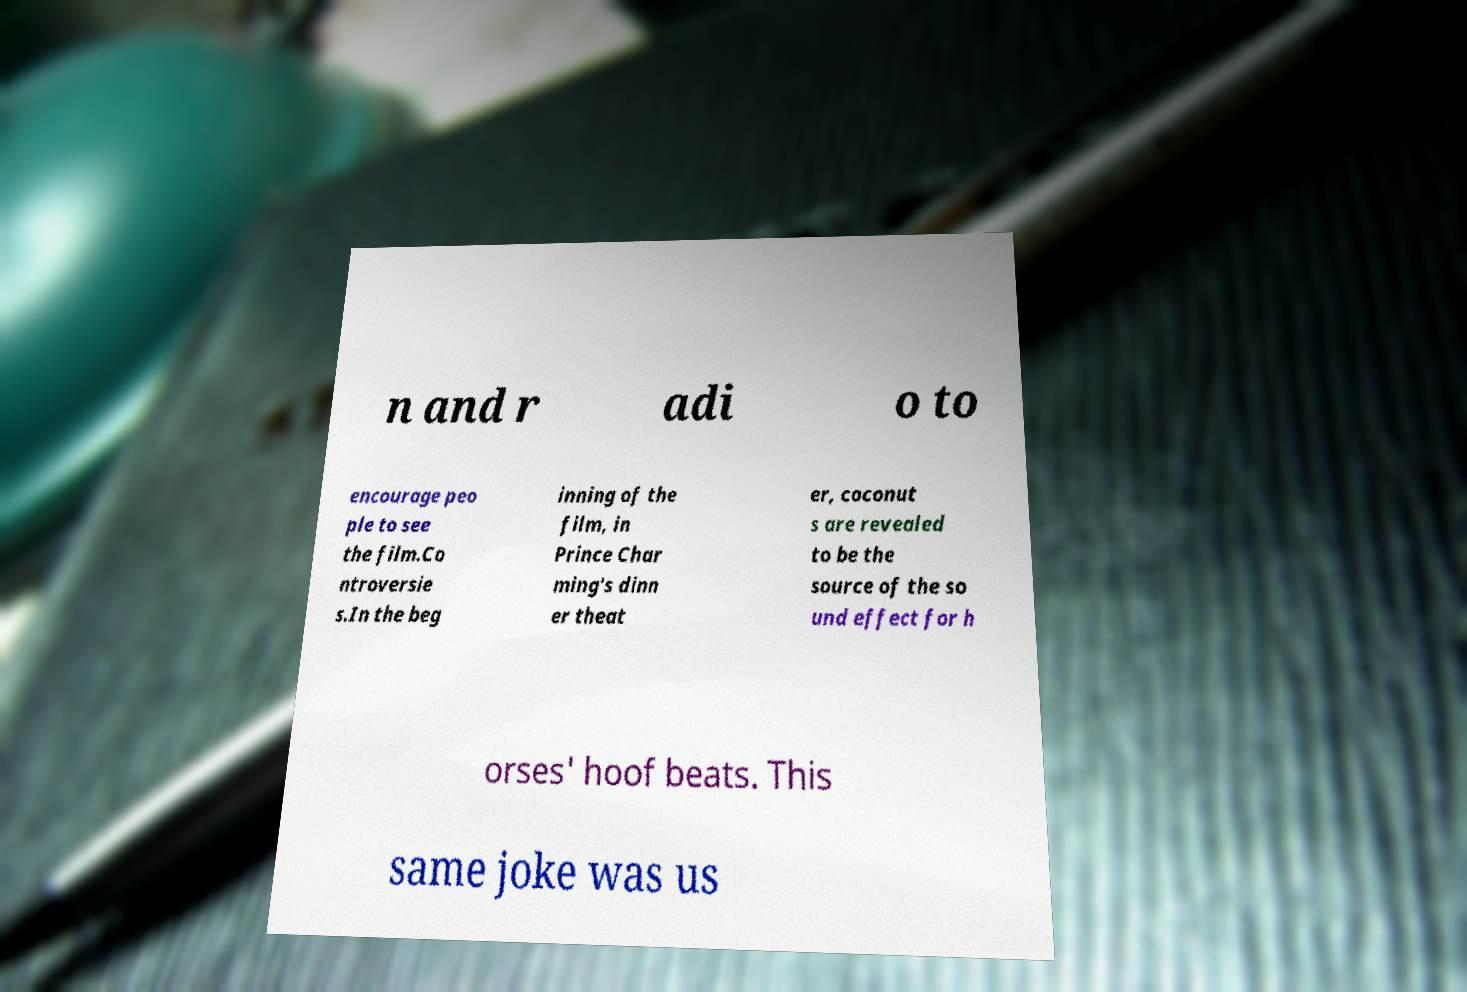For documentation purposes, I need the text within this image transcribed. Could you provide that? n and r adi o to encourage peo ple to see the film.Co ntroversie s.In the beg inning of the film, in Prince Char ming's dinn er theat er, coconut s are revealed to be the source of the so und effect for h orses' hoof beats. This same joke was us 